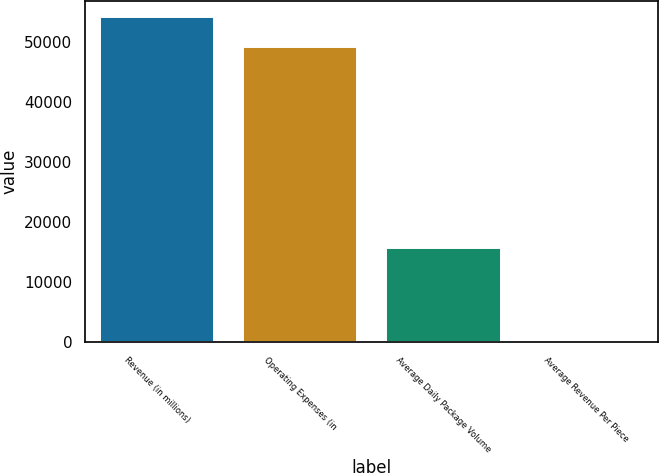Convert chart to OTSL. <chart><loc_0><loc_0><loc_500><loc_500><bar_chart><fcel>Revenue (in millions)<fcel>Operating Expenses (in<fcel>Average Daily Package Volume<fcel>Average Revenue Per Piece<nl><fcel>54082.2<fcel>49114<fcel>15750<fcel>10.24<nl></chart> 